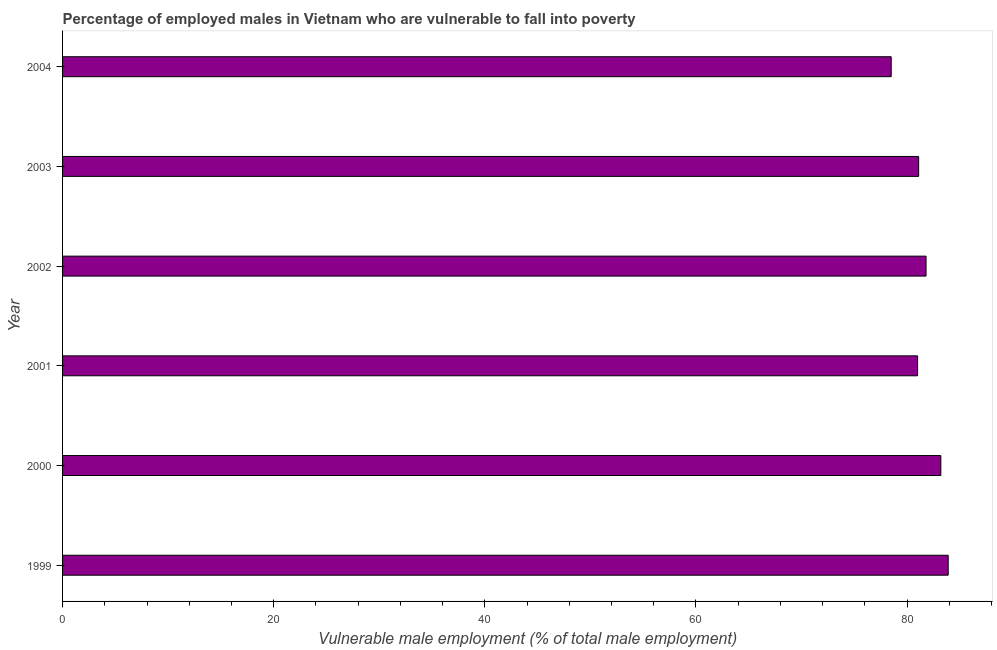Does the graph contain any zero values?
Keep it short and to the point. No. What is the title of the graph?
Give a very brief answer. Percentage of employed males in Vietnam who are vulnerable to fall into poverty. What is the label or title of the X-axis?
Offer a very short reply. Vulnerable male employment (% of total male employment). What is the percentage of employed males who are vulnerable to fall into poverty in 2003?
Provide a short and direct response. 81.1. Across all years, what is the maximum percentage of employed males who are vulnerable to fall into poverty?
Offer a very short reply. 83.9. Across all years, what is the minimum percentage of employed males who are vulnerable to fall into poverty?
Ensure brevity in your answer.  78.5. In which year was the percentage of employed males who are vulnerable to fall into poverty minimum?
Provide a succinct answer. 2004. What is the sum of the percentage of employed males who are vulnerable to fall into poverty?
Give a very brief answer. 489.5. What is the difference between the percentage of employed males who are vulnerable to fall into poverty in 2003 and 2004?
Make the answer very short. 2.6. What is the average percentage of employed males who are vulnerable to fall into poverty per year?
Ensure brevity in your answer.  81.58. What is the median percentage of employed males who are vulnerable to fall into poverty?
Your response must be concise. 81.45. Do a majority of the years between 2000 and 2001 (inclusive) have percentage of employed males who are vulnerable to fall into poverty greater than 64 %?
Provide a succinct answer. Yes. What is the ratio of the percentage of employed males who are vulnerable to fall into poverty in 2001 to that in 2003?
Offer a very short reply. 1. Is the percentage of employed males who are vulnerable to fall into poverty in 2000 less than that in 2003?
Make the answer very short. No. Is the difference between the percentage of employed males who are vulnerable to fall into poverty in 1999 and 2001 greater than the difference between any two years?
Make the answer very short. No. What is the difference between the highest and the second highest percentage of employed males who are vulnerable to fall into poverty?
Your response must be concise. 0.7. What is the difference between the highest and the lowest percentage of employed males who are vulnerable to fall into poverty?
Your answer should be very brief. 5.4. In how many years, is the percentage of employed males who are vulnerable to fall into poverty greater than the average percentage of employed males who are vulnerable to fall into poverty taken over all years?
Your answer should be very brief. 3. Are all the bars in the graph horizontal?
Make the answer very short. Yes. What is the difference between two consecutive major ticks on the X-axis?
Keep it short and to the point. 20. What is the Vulnerable male employment (% of total male employment) of 1999?
Offer a terse response. 83.9. What is the Vulnerable male employment (% of total male employment) in 2000?
Your answer should be very brief. 83.2. What is the Vulnerable male employment (% of total male employment) of 2001?
Ensure brevity in your answer.  81. What is the Vulnerable male employment (% of total male employment) in 2002?
Ensure brevity in your answer.  81.8. What is the Vulnerable male employment (% of total male employment) in 2003?
Your response must be concise. 81.1. What is the Vulnerable male employment (% of total male employment) of 2004?
Offer a terse response. 78.5. What is the difference between the Vulnerable male employment (% of total male employment) in 1999 and 2001?
Your answer should be very brief. 2.9. What is the difference between the Vulnerable male employment (% of total male employment) in 1999 and 2002?
Make the answer very short. 2.1. What is the difference between the Vulnerable male employment (% of total male employment) in 1999 and 2004?
Your response must be concise. 5.4. What is the difference between the Vulnerable male employment (% of total male employment) in 2000 and 2002?
Your answer should be very brief. 1.4. What is the difference between the Vulnerable male employment (% of total male employment) in 2001 and 2002?
Your answer should be compact. -0.8. What is the difference between the Vulnerable male employment (% of total male employment) in 2002 and 2004?
Your response must be concise. 3.3. What is the ratio of the Vulnerable male employment (% of total male employment) in 1999 to that in 2000?
Offer a terse response. 1.01. What is the ratio of the Vulnerable male employment (% of total male employment) in 1999 to that in 2001?
Your response must be concise. 1.04. What is the ratio of the Vulnerable male employment (% of total male employment) in 1999 to that in 2002?
Provide a short and direct response. 1.03. What is the ratio of the Vulnerable male employment (% of total male employment) in 1999 to that in 2003?
Keep it short and to the point. 1.03. What is the ratio of the Vulnerable male employment (% of total male employment) in 1999 to that in 2004?
Your response must be concise. 1.07. What is the ratio of the Vulnerable male employment (% of total male employment) in 2000 to that in 2002?
Offer a very short reply. 1.02. What is the ratio of the Vulnerable male employment (% of total male employment) in 2000 to that in 2003?
Offer a terse response. 1.03. What is the ratio of the Vulnerable male employment (% of total male employment) in 2000 to that in 2004?
Give a very brief answer. 1.06. What is the ratio of the Vulnerable male employment (% of total male employment) in 2001 to that in 2003?
Your answer should be compact. 1. What is the ratio of the Vulnerable male employment (% of total male employment) in 2001 to that in 2004?
Make the answer very short. 1.03. What is the ratio of the Vulnerable male employment (% of total male employment) in 2002 to that in 2004?
Offer a very short reply. 1.04. What is the ratio of the Vulnerable male employment (% of total male employment) in 2003 to that in 2004?
Make the answer very short. 1.03. 